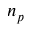Convert formula to latex. <formula><loc_0><loc_0><loc_500><loc_500>n _ { p }</formula> 